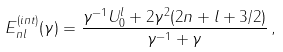Convert formula to latex. <formula><loc_0><loc_0><loc_500><loc_500>E _ { n l } ^ { ( i n t ) } ( \gamma ) = \frac { \gamma ^ { - 1 } U _ { 0 } ^ { l } + 2 \gamma ^ { 2 } ( 2 n + l + 3 / 2 ) } { \gamma ^ { - 1 } + \gamma } \, ,</formula> 